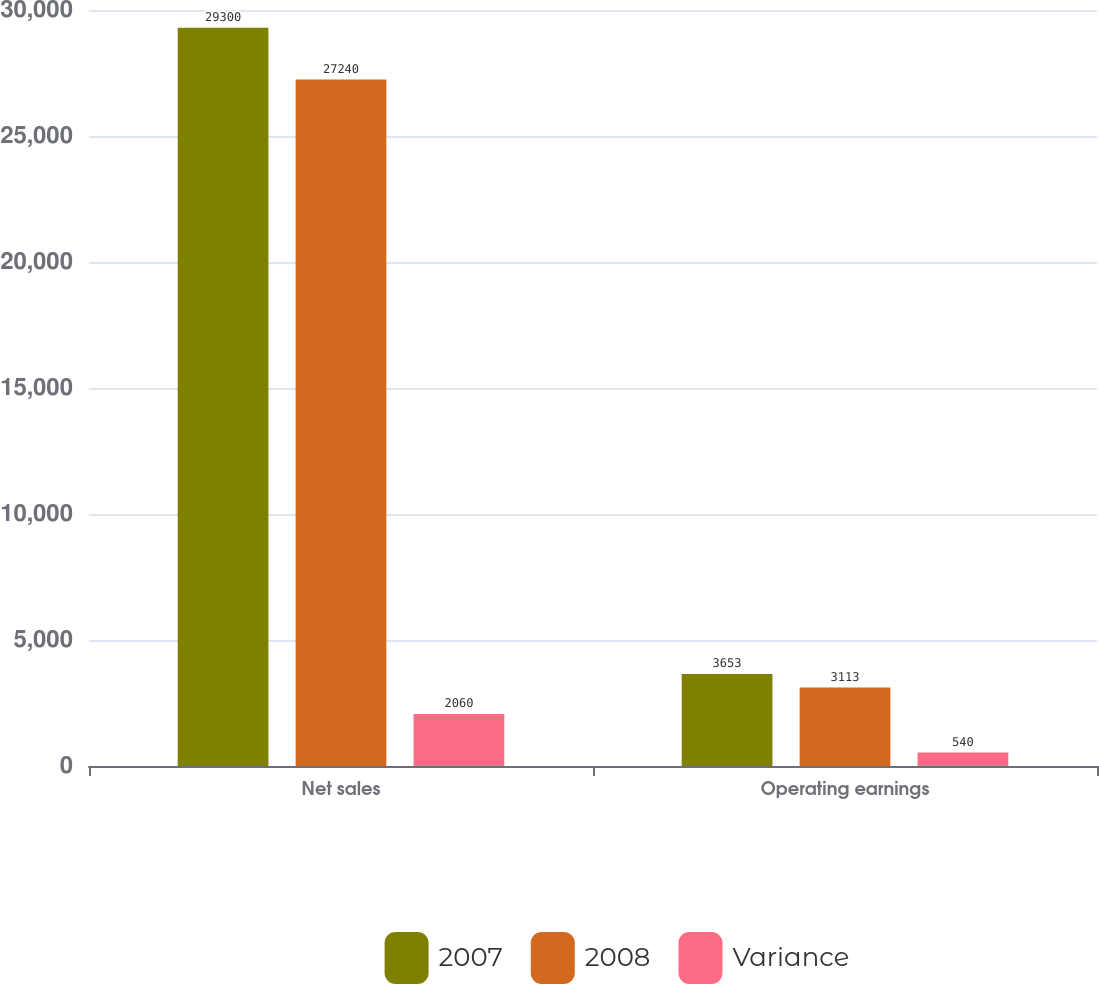Convert chart to OTSL. <chart><loc_0><loc_0><loc_500><loc_500><stacked_bar_chart><ecel><fcel>Net sales<fcel>Operating earnings<nl><fcel>2007<fcel>29300<fcel>3653<nl><fcel>2008<fcel>27240<fcel>3113<nl><fcel>Variance<fcel>2060<fcel>540<nl></chart> 